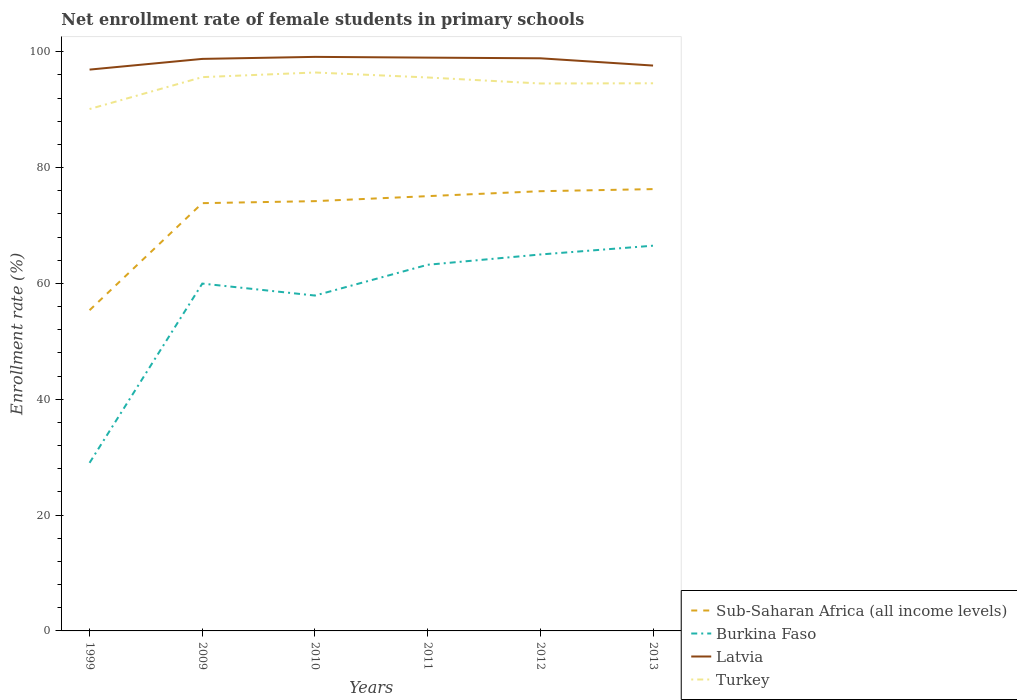How many different coloured lines are there?
Provide a succinct answer. 4. Does the line corresponding to Latvia intersect with the line corresponding to Sub-Saharan Africa (all income levels)?
Provide a succinct answer. No. Is the number of lines equal to the number of legend labels?
Offer a very short reply. Yes. Across all years, what is the maximum net enrollment rate of female students in primary schools in Latvia?
Offer a terse response. 96.93. What is the total net enrollment rate of female students in primary schools in Burkina Faso in the graph?
Ensure brevity in your answer.  -1.78. What is the difference between the highest and the second highest net enrollment rate of female students in primary schools in Sub-Saharan Africa (all income levels)?
Provide a succinct answer. 20.91. How many years are there in the graph?
Your response must be concise. 6. Are the values on the major ticks of Y-axis written in scientific E-notation?
Your response must be concise. No. Does the graph contain any zero values?
Your response must be concise. No. What is the title of the graph?
Provide a short and direct response. Net enrollment rate of female students in primary schools. What is the label or title of the Y-axis?
Your answer should be compact. Enrollment rate (%). What is the Enrollment rate (%) in Sub-Saharan Africa (all income levels) in 1999?
Make the answer very short. 55.38. What is the Enrollment rate (%) in Burkina Faso in 1999?
Offer a terse response. 29.03. What is the Enrollment rate (%) of Latvia in 1999?
Offer a terse response. 96.93. What is the Enrollment rate (%) in Turkey in 1999?
Offer a very short reply. 90.12. What is the Enrollment rate (%) of Sub-Saharan Africa (all income levels) in 2009?
Make the answer very short. 73.87. What is the Enrollment rate (%) of Burkina Faso in 2009?
Offer a very short reply. 59.98. What is the Enrollment rate (%) in Latvia in 2009?
Ensure brevity in your answer.  98.78. What is the Enrollment rate (%) in Turkey in 2009?
Ensure brevity in your answer.  95.63. What is the Enrollment rate (%) in Sub-Saharan Africa (all income levels) in 2010?
Provide a succinct answer. 74.21. What is the Enrollment rate (%) in Burkina Faso in 2010?
Offer a very short reply. 57.91. What is the Enrollment rate (%) of Latvia in 2010?
Make the answer very short. 99.13. What is the Enrollment rate (%) in Turkey in 2010?
Your response must be concise. 96.43. What is the Enrollment rate (%) of Sub-Saharan Africa (all income levels) in 2011?
Offer a very short reply. 75.08. What is the Enrollment rate (%) in Burkina Faso in 2011?
Make the answer very short. 63.23. What is the Enrollment rate (%) in Latvia in 2011?
Your response must be concise. 99. What is the Enrollment rate (%) of Turkey in 2011?
Make the answer very short. 95.57. What is the Enrollment rate (%) in Sub-Saharan Africa (all income levels) in 2012?
Offer a terse response. 75.93. What is the Enrollment rate (%) in Burkina Faso in 2012?
Offer a very short reply. 65. What is the Enrollment rate (%) in Latvia in 2012?
Keep it short and to the point. 98.88. What is the Enrollment rate (%) of Turkey in 2012?
Give a very brief answer. 94.53. What is the Enrollment rate (%) in Sub-Saharan Africa (all income levels) in 2013?
Make the answer very short. 76.29. What is the Enrollment rate (%) in Burkina Faso in 2013?
Provide a succinct answer. 66.52. What is the Enrollment rate (%) of Latvia in 2013?
Ensure brevity in your answer.  97.63. What is the Enrollment rate (%) in Turkey in 2013?
Provide a succinct answer. 94.57. Across all years, what is the maximum Enrollment rate (%) of Sub-Saharan Africa (all income levels)?
Ensure brevity in your answer.  76.29. Across all years, what is the maximum Enrollment rate (%) of Burkina Faso?
Provide a short and direct response. 66.52. Across all years, what is the maximum Enrollment rate (%) in Latvia?
Offer a terse response. 99.13. Across all years, what is the maximum Enrollment rate (%) in Turkey?
Your answer should be very brief. 96.43. Across all years, what is the minimum Enrollment rate (%) of Sub-Saharan Africa (all income levels)?
Give a very brief answer. 55.38. Across all years, what is the minimum Enrollment rate (%) in Burkina Faso?
Your answer should be compact. 29.03. Across all years, what is the minimum Enrollment rate (%) of Latvia?
Your response must be concise. 96.93. Across all years, what is the minimum Enrollment rate (%) of Turkey?
Offer a very short reply. 90.12. What is the total Enrollment rate (%) in Sub-Saharan Africa (all income levels) in the graph?
Make the answer very short. 430.76. What is the total Enrollment rate (%) of Burkina Faso in the graph?
Offer a very short reply. 341.67. What is the total Enrollment rate (%) in Latvia in the graph?
Your answer should be compact. 590.34. What is the total Enrollment rate (%) in Turkey in the graph?
Provide a succinct answer. 566.85. What is the difference between the Enrollment rate (%) in Sub-Saharan Africa (all income levels) in 1999 and that in 2009?
Offer a terse response. -18.49. What is the difference between the Enrollment rate (%) of Burkina Faso in 1999 and that in 2009?
Keep it short and to the point. -30.95. What is the difference between the Enrollment rate (%) of Latvia in 1999 and that in 2009?
Your response must be concise. -1.85. What is the difference between the Enrollment rate (%) in Turkey in 1999 and that in 2009?
Provide a short and direct response. -5.51. What is the difference between the Enrollment rate (%) in Sub-Saharan Africa (all income levels) in 1999 and that in 2010?
Offer a terse response. -18.83. What is the difference between the Enrollment rate (%) of Burkina Faso in 1999 and that in 2010?
Make the answer very short. -28.89. What is the difference between the Enrollment rate (%) in Latvia in 1999 and that in 2010?
Offer a terse response. -2.2. What is the difference between the Enrollment rate (%) in Turkey in 1999 and that in 2010?
Provide a short and direct response. -6.31. What is the difference between the Enrollment rate (%) in Sub-Saharan Africa (all income levels) in 1999 and that in 2011?
Your answer should be compact. -19.7. What is the difference between the Enrollment rate (%) in Burkina Faso in 1999 and that in 2011?
Keep it short and to the point. -34.2. What is the difference between the Enrollment rate (%) in Latvia in 1999 and that in 2011?
Give a very brief answer. -2.07. What is the difference between the Enrollment rate (%) of Turkey in 1999 and that in 2011?
Your response must be concise. -5.45. What is the difference between the Enrollment rate (%) of Sub-Saharan Africa (all income levels) in 1999 and that in 2012?
Make the answer very short. -20.55. What is the difference between the Enrollment rate (%) in Burkina Faso in 1999 and that in 2012?
Offer a very short reply. -35.98. What is the difference between the Enrollment rate (%) of Latvia in 1999 and that in 2012?
Give a very brief answer. -1.95. What is the difference between the Enrollment rate (%) in Turkey in 1999 and that in 2012?
Your answer should be very brief. -4.41. What is the difference between the Enrollment rate (%) in Sub-Saharan Africa (all income levels) in 1999 and that in 2013?
Ensure brevity in your answer.  -20.91. What is the difference between the Enrollment rate (%) of Burkina Faso in 1999 and that in 2013?
Offer a very short reply. -37.5. What is the difference between the Enrollment rate (%) in Latvia in 1999 and that in 2013?
Your answer should be compact. -0.7. What is the difference between the Enrollment rate (%) in Turkey in 1999 and that in 2013?
Give a very brief answer. -4.45. What is the difference between the Enrollment rate (%) of Sub-Saharan Africa (all income levels) in 2009 and that in 2010?
Offer a very short reply. -0.35. What is the difference between the Enrollment rate (%) of Burkina Faso in 2009 and that in 2010?
Your answer should be very brief. 2.07. What is the difference between the Enrollment rate (%) of Latvia in 2009 and that in 2010?
Your response must be concise. -0.35. What is the difference between the Enrollment rate (%) in Turkey in 2009 and that in 2010?
Give a very brief answer. -0.8. What is the difference between the Enrollment rate (%) in Sub-Saharan Africa (all income levels) in 2009 and that in 2011?
Give a very brief answer. -1.21. What is the difference between the Enrollment rate (%) of Burkina Faso in 2009 and that in 2011?
Offer a terse response. -3.25. What is the difference between the Enrollment rate (%) of Latvia in 2009 and that in 2011?
Ensure brevity in your answer.  -0.22. What is the difference between the Enrollment rate (%) of Turkey in 2009 and that in 2011?
Provide a succinct answer. 0.06. What is the difference between the Enrollment rate (%) of Sub-Saharan Africa (all income levels) in 2009 and that in 2012?
Make the answer very short. -2.06. What is the difference between the Enrollment rate (%) in Burkina Faso in 2009 and that in 2012?
Give a very brief answer. -5.03. What is the difference between the Enrollment rate (%) in Latvia in 2009 and that in 2012?
Provide a short and direct response. -0.1. What is the difference between the Enrollment rate (%) in Turkey in 2009 and that in 2012?
Provide a succinct answer. 1.1. What is the difference between the Enrollment rate (%) of Sub-Saharan Africa (all income levels) in 2009 and that in 2013?
Your answer should be very brief. -2.43. What is the difference between the Enrollment rate (%) in Burkina Faso in 2009 and that in 2013?
Provide a short and direct response. -6.54. What is the difference between the Enrollment rate (%) of Latvia in 2009 and that in 2013?
Your answer should be compact. 1.15. What is the difference between the Enrollment rate (%) of Turkey in 2009 and that in 2013?
Keep it short and to the point. 1.06. What is the difference between the Enrollment rate (%) of Sub-Saharan Africa (all income levels) in 2010 and that in 2011?
Offer a terse response. -0.86. What is the difference between the Enrollment rate (%) in Burkina Faso in 2010 and that in 2011?
Provide a short and direct response. -5.32. What is the difference between the Enrollment rate (%) in Latvia in 2010 and that in 2011?
Your answer should be very brief. 0.13. What is the difference between the Enrollment rate (%) of Turkey in 2010 and that in 2011?
Provide a short and direct response. 0.86. What is the difference between the Enrollment rate (%) in Sub-Saharan Africa (all income levels) in 2010 and that in 2012?
Make the answer very short. -1.72. What is the difference between the Enrollment rate (%) of Burkina Faso in 2010 and that in 2012?
Your response must be concise. -7.09. What is the difference between the Enrollment rate (%) in Latvia in 2010 and that in 2012?
Your response must be concise. 0.24. What is the difference between the Enrollment rate (%) in Turkey in 2010 and that in 2012?
Provide a succinct answer. 1.9. What is the difference between the Enrollment rate (%) in Sub-Saharan Africa (all income levels) in 2010 and that in 2013?
Your answer should be compact. -2.08. What is the difference between the Enrollment rate (%) of Burkina Faso in 2010 and that in 2013?
Offer a very short reply. -8.61. What is the difference between the Enrollment rate (%) of Latvia in 2010 and that in 2013?
Provide a short and direct response. 1.5. What is the difference between the Enrollment rate (%) in Turkey in 2010 and that in 2013?
Ensure brevity in your answer.  1.86. What is the difference between the Enrollment rate (%) of Sub-Saharan Africa (all income levels) in 2011 and that in 2012?
Provide a short and direct response. -0.85. What is the difference between the Enrollment rate (%) of Burkina Faso in 2011 and that in 2012?
Give a very brief answer. -1.78. What is the difference between the Enrollment rate (%) in Latvia in 2011 and that in 2012?
Offer a terse response. 0.12. What is the difference between the Enrollment rate (%) of Turkey in 2011 and that in 2012?
Offer a very short reply. 1.04. What is the difference between the Enrollment rate (%) in Sub-Saharan Africa (all income levels) in 2011 and that in 2013?
Provide a succinct answer. -1.22. What is the difference between the Enrollment rate (%) of Burkina Faso in 2011 and that in 2013?
Your response must be concise. -3.29. What is the difference between the Enrollment rate (%) in Latvia in 2011 and that in 2013?
Offer a terse response. 1.37. What is the difference between the Enrollment rate (%) of Sub-Saharan Africa (all income levels) in 2012 and that in 2013?
Offer a terse response. -0.36. What is the difference between the Enrollment rate (%) in Burkina Faso in 2012 and that in 2013?
Your answer should be very brief. -1.52. What is the difference between the Enrollment rate (%) of Latvia in 2012 and that in 2013?
Keep it short and to the point. 1.26. What is the difference between the Enrollment rate (%) in Turkey in 2012 and that in 2013?
Your response must be concise. -0.03. What is the difference between the Enrollment rate (%) of Sub-Saharan Africa (all income levels) in 1999 and the Enrollment rate (%) of Burkina Faso in 2009?
Offer a terse response. -4.6. What is the difference between the Enrollment rate (%) of Sub-Saharan Africa (all income levels) in 1999 and the Enrollment rate (%) of Latvia in 2009?
Your response must be concise. -43.4. What is the difference between the Enrollment rate (%) in Sub-Saharan Africa (all income levels) in 1999 and the Enrollment rate (%) in Turkey in 2009?
Make the answer very short. -40.25. What is the difference between the Enrollment rate (%) in Burkina Faso in 1999 and the Enrollment rate (%) in Latvia in 2009?
Make the answer very short. -69.75. What is the difference between the Enrollment rate (%) in Burkina Faso in 1999 and the Enrollment rate (%) in Turkey in 2009?
Provide a succinct answer. -66.6. What is the difference between the Enrollment rate (%) in Latvia in 1999 and the Enrollment rate (%) in Turkey in 2009?
Keep it short and to the point. 1.3. What is the difference between the Enrollment rate (%) in Sub-Saharan Africa (all income levels) in 1999 and the Enrollment rate (%) in Burkina Faso in 2010?
Your response must be concise. -2.53. What is the difference between the Enrollment rate (%) in Sub-Saharan Africa (all income levels) in 1999 and the Enrollment rate (%) in Latvia in 2010?
Offer a very short reply. -43.75. What is the difference between the Enrollment rate (%) in Sub-Saharan Africa (all income levels) in 1999 and the Enrollment rate (%) in Turkey in 2010?
Give a very brief answer. -41.05. What is the difference between the Enrollment rate (%) of Burkina Faso in 1999 and the Enrollment rate (%) of Latvia in 2010?
Provide a short and direct response. -70.1. What is the difference between the Enrollment rate (%) in Burkina Faso in 1999 and the Enrollment rate (%) in Turkey in 2010?
Offer a terse response. -67.4. What is the difference between the Enrollment rate (%) of Latvia in 1999 and the Enrollment rate (%) of Turkey in 2010?
Ensure brevity in your answer.  0.5. What is the difference between the Enrollment rate (%) in Sub-Saharan Africa (all income levels) in 1999 and the Enrollment rate (%) in Burkina Faso in 2011?
Offer a terse response. -7.85. What is the difference between the Enrollment rate (%) of Sub-Saharan Africa (all income levels) in 1999 and the Enrollment rate (%) of Latvia in 2011?
Give a very brief answer. -43.62. What is the difference between the Enrollment rate (%) in Sub-Saharan Africa (all income levels) in 1999 and the Enrollment rate (%) in Turkey in 2011?
Your answer should be compact. -40.19. What is the difference between the Enrollment rate (%) of Burkina Faso in 1999 and the Enrollment rate (%) of Latvia in 2011?
Give a very brief answer. -69.97. What is the difference between the Enrollment rate (%) in Burkina Faso in 1999 and the Enrollment rate (%) in Turkey in 2011?
Provide a succinct answer. -66.54. What is the difference between the Enrollment rate (%) of Latvia in 1999 and the Enrollment rate (%) of Turkey in 2011?
Provide a short and direct response. 1.36. What is the difference between the Enrollment rate (%) of Sub-Saharan Africa (all income levels) in 1999 and the Enrollment rate (%) of Burkina Faso in 2012?
Give a very brief answer. -9.62. What is the difference between the Enrollment rate (%) of Sub-Saharan Africa (all income levels) in 1999 and the Enrollment rate (%) of Latvia in 2012?
Make the answer very short. -43.5. What is the difference between the Enrollment rate (%) in Sub-Saharan Africa (all income levels) in 1999 and the Enrollment rate (%) in Turkey in 2012?
Offer a very short reply. -39.15. What is the difference between the Enrollment rate (%) of Burkina Faso in 1999 and the Enrollment rate (%) of Latvia in 2012?
Give a very brief answer. -69.86. What is the difference between the Enrollment rate (%) of Burkina Faso in 1999 and the Enrollment rate (%) of Turkey in 2012?
Make the answer very short. -65.51. What is the difference between the Enrollment rate (%) in Latvia in 1999 and the Enrollment rate (%) in Turkey in 2012?
Give a very brief answer. 2.4. What is the difference between the Enrollment rate (%) in Sub-Saharan Africa (all income levels) in 1999 and the Enrollment rate (%) in Burkina Faso in 2013?
Offer a very short reply. -11.14. What is the difference between the Enrollment rate (%) in Sub-Saharan Africa (all income levels) in 1999 and the Enrollment rate (%) in Latvia in 2013?
Your answer should be very brief. -42.25. What is the difference between the Enrollment rate (%) in Sub-Saharan Africa (all income levels) in 1999 and the Enrollment rate (%) in Turkey in 2013?
Offer a very short reply. -39.19. What is the difference between the Enrollment rate (%) of Burkina Faso in 1999 and the Enrollment rate (%) of Latvia in 2013?
Your answer should be very brief. -68.6. What is the difference between the Enrollment rate (%) in Burkina Faso in 1999 and the Enrollment rate (%) in Turkey in 2013?
Your answer should be compact. -65.54. What is the difference between the Enrollment rate (%) of Latvia in 1999 and the Enrollment rate (%) of Turkey in 2013?
Make the answer very short. 2.36. What is the difference between the Enrollment rate (%) of Sub-Saharan Africa (all income levels) in 2009 and the Enrollment rate (%) of Burkina Faso in 2010?
Give a very brief answer. 15.95. What is the difference between the Enrollment rate (%) of Sub-Saharan Africa (all income levels) in 2009 and the Enrollment rate (%) of Latvia in 2010?
Your response must be concise. -25.26. What is the difference between the Enrollment rate (%) of Sub-Saharan Africa (all income levels) in 2009 and the Enrollment rate (%) of Turkey in 2010?
Your answer should be very brief. -22.56. What is the difference between the Enrollment rate (%) in Burkina Faso in 2009 and the Enrollment rate (%) in Latvia in 2010?
Provide a succinct answer. -39.15. What is the difference between the Enrollment rate (%) in Burkina Faso in 2009 and the Enrollment rate (%) in Turkey in 2010?
Keep it short and to the point. -36.45. What is the difference between the Enrollment rate (%) in Latvia in 2009 and the Enrollment rate (%) in Turkey in 2010?
Your response must be concise. 2.35. What is the difference between the Enrollment rate (%) in Sub-Saharan Africa (all income levels) in 2009 and the Enrollment rate (%) in Burkina Faso in 2011?
Ensure brevity in your answer.  10.64. What is the difference between the Enrollment rate (%) in Sub-Saharan Africa (all income levels) in 2009 and the Enrollment rate (%) in Latvia in 2011?
Offer a very short reply. -25.13. What is the difference between the Enrollment rate (%) in Sub-Saharan Africa (all income levels) in 2009 and the Enrollment rate (%) in Turkey in 2011?
Provide a succinct answer. -21.7. What is the difference between the Enrollment rate (%) of Burkina Faso in 2009 and the Enrollment rate (%) of Latvia in 2011?
Offer a very short reply. -39.02. What is the difference between the Enrollment rate (%) of Burkina Faso in 2009 and the Enrollment rate (%) of Turkey in 2011?
Your answer should be compact. -35.59. What is the difference between the Enrollment rate (%) of Latvia in 2009 and the Enrollment rate (%) of Turkey in 2011?
Make the answer very short. 3.21. What is the difference between the Enrollment rate (%) of Sub-Saharan Africa (all income levels) in 2009 and the Enrollment rate (%) of Burkina Faso in 2012?
Offer a very short reply. 8.86. What is the difference between the Enrollment rate (%) of Sub-Saharan Africa (all income levels) in 2009 and the Enrollment rate (%) of Latvia in 2012?
Keep it short and to the point. -25.02. What is the difference between the Enrollment rate (%) of Sub-Saharan Africa (all income levels) in 2009 and the Enrollment rate (%) of Turkey in 2012?
Make the answer very short. -20.67. What is the difference between the Enrollment rate (%) of Burkina Faso in 2009 and the Enrollment rate (%) of Latvia in 2012?
Keep it short and to the point. -38.9. What is the difference between the Enrollment rate (%) of Burkina Faso in 2009 and the Enrollment rate (%) of Turkey in 2012?
Keep it short and to the point. -34.55. What is the difference between the Enrollment rate (%) of Latvia in 2009 and the Enrollment rate (%) of Turkey in 2012?
Your answer should be compact. 4.25. What is the difference between the Enrollment rate (%) in Sub-Saharan Africa (all income levels) in 2009 and the Enrollment rate (%) in Burkina Faso in 2013?
Offer a terse response. 7.34. What is the difference between the Enrollment rate (%) in Sub-Saharan Africa (all income levels) in 2009 and the Enrollment rate (%) in Latvia in 2013?
Keep it short and to the point. -23.76. What is the difference between the Enrollment rate (%) in Sub-Saharan Africa (all income levels) in 2009 and the Enrollment rate (%) in Turkey in 2013?
Give a very brief answer. -20.7. What is the difference between the Enrollment rate (%) of Burkina Faso in 2009 and the Enrollment rate (%) of Latvia in 2013?
Provide a short and direct response. -37.65. What is the difference between the Enrollment rate (%) in Burkina Faso in 2009 and the Enrollment rate (%) in Turkey in 2013?
Your answer should be compact. -34.59. What is the difference between the Enrollment rate (%) of Latvia in 2009 and the Enrollment rate (%) of Turkey in 2013?
Keep it short and to the point. 4.21. What is the difference between the Enrollment rate (%) in Sub-Saharan Africa (all income levels) in 2010 and the Enrollment rate (%) in Burkina Faso in 2011?
Provide a succinct answer. 10.99. What is the difference between the Enrollment rate (%) of Sub-Saharan Africa (all income levels) in 2010 and the Enrollment rate (%) of Latvia in 2011?
Your response must be concise. -24.78. What is the difference between the Enrollment rate (%) of Sub-Saharan Africa (all income levels) in 2010 and the Enrollment rate (%) of Turkey in 2011?
Provide a short and direct response. -21.36. What is the difference between the Enrollment rate (%) in Burkina Faso in 2010 and the Enrollment rate (%) in Latvia in 2011?
Give a very brief answer. -41.09. What is the difference between the Enrollment rate (%) of Burkina Faso in 2010 and the Enrollment rate (%) of Turkey in 2011?
Keep it short and to the point. -37.66. What is the difference between the Enrollment rate (%) in Latvia in 2010 and the Enrollment rate (%) in Turkey in 2011?
Ensure brevity in your answer.  3.56. What is the difference between the Enrollment rate (%) in Sub-Saharan Africa (all income levels) in 2010 and the Enrollment rate (%) in Burkina Faso in 2012?
Offer a terse response. 9.21. What is the difference between the Enrollment rate (%) in Sub-Saharan Africa (all income levels) in 2010 and the Enrollment rate (%) in Latvia in 2012?
Keep it short and to the point. -24.67. What is the difference between the Enrollment rate (%) in Sub-Saharan Africa (all income levels) in 2010 and the Enrollment rate (%) in Turkey in 2012?
Keep it short and to the point. -20.32. What is the difference between the Enrollment rate (%) in Burkina Faso in 2010 and the Enrollment rate (%) in Latvia in 2012?
Your response must be concise. -40.97. What is the difference between the Enrollment rate (%) of Burkina Faso in 2010 and the Enrollment rate (%) of Turkey in 2012?
Keep it short and to the point. -36.62. What is the difference between the Enrollment rate (%) of Latvia in 2010 and the Enrollment rate (%) of Turkey in 2012?
Provide a succinct answer. 4.59. What is the difference between the Enrollment rate (%) of Sub-Saharan Africa (all income levels) in 2010 and the Enrollment rate (%) of Burkina Faso in 2013?
Offer a very short reply. 7.69. What is the difference between the Enrollment rate (%) of Sub-Saharan Africa (all income levels) in 2010 and the Enrollment rate (%) of Latvia in 2013?
Your response must be concise. -23.41. What is the difference between the Enrollment rate (%) of Sub-Saharan Africa (all income levels) in 2010 and the Enrollment rate (%) of Turkey in 2013?
Keep it short and to the point. -20.35. What is the difference between the Enrollment rate (%) in Burkina Faso in 2010 and the Enrollment rate (%) in Latvia in 2013?
Make the answer very short. -39.71. What is the difference between the Enrollment rate (%) in Burkina Faso in 2010 and the Enrollment rate (%) in Turkey in 2013?
Provide a succinct answer. -36.65. What is the difference between the Enrollment rate (%) of Latvia in 2010 and the Enrollment rate (%) of Turkey in 2013?
Give a very brief answer. 4.56. What is the difference between the Enrollment rate (%) in Sub-Saharan Africa (all income levels) in 2011 and the Enrollment rate (%) in Burkina Faso in 2012?
Provide a short and direct response. 10.07. What is the difference between the Enrollment rate (%) in Sub-Saharan Africa (all income levels) in 2011 and the Enrollment rate (%) in Latvia in 2012?
Keep it short and to the point. -23.8. What is the difference between the Enrollment rate (%) of Sub-Saharan Africa (all income levels) in 2011 and the Enrollment rate (%) of Turkey in 2012?
Your response must be concise. -19.46. What is the difference between the Enrollment rate (%) in Burkina Faso in 2011 and the Enrollment rate (%) in Latvia in 2012?
Offer a very short reply. -35.65. What is the difference between the Enrollment rate (%) of Burkina Faso in 2011 and the Enrollment rate (%) of Turkey in 2012?
Make the answer very short. -31.3. What is the difference between the Enrollment rate (%) in Latvia in 2011 and the Enrollment rate (%) in Turkey in 2012?
Keep it short and to the point. 4.47. What is the difference between the Enrollment rate (%) of Sub-Saharan Africa (all income levels) in 2011 and the Enrollment rate (%) of Burkina Faso in 2013?
Keep it short and to the point. 8.56. What is the difference between the Enrollment rate (%) of Sub-Saharan Africa (all income levels) in 2011 and the Enrollment rate (%) of Latvia in 2013?
Ensure brevity in your answer.  -22.55. What is the difference between the Enrollment rate (%) of Sub-Saharan Africa (all income levels) in 2011 and the Enrollment rate (%) of Turkey in 2013?
Ensure brevity in your answer.  -19.49. What is the difference between the Enrollment rate (%) of Burkina Faso in 2011 and the Enrollment rate (%) of Latvia in 2013?
Your answer should be compact. -34.4. What is the difference between the Enrollment rate (%) in Burkina Faso in 2011 and the Enrollment rate (%) in Turkey in 2013?
Keep it short and to the point. -31.34. What is the difference between the Enrollment rate (%) in Latvia in 2011 and the Enrollment rate (%) in Turkey in 2013?
Offer a very short reply. 4.43. What is the difference between the Enrollment rate (%) in Sub-Saharan Africa (all income levels) in 2012 and the Enrollment rate (%) in Burkina Faso in 2013?
Provide a succinct answer. 9.41. What is the difference between the Enrollment rate (%) of Sub-Saharan Africa (all income levels) in 2012 and the Enrollment rate (%) of Latvia in 2013?
Keep it short and to the point. -21.7. What is the difference between the Enrollment rate (%) of Sub-Saharan Africa (all income levels) in 2012 and the Enrollment rate (%) of Turkey in 2013?
Your answer should be compact. -18.64. What is the difference between the Enrollment rate (%) of Burkina Faso in 2012 and the Enrollment rate (%) of Latvia in 2013?
Keep it short and to the point. -32.62. What is the difference between the Enrollment rate (%) of Burkina Faso in 2012 and the Enrollment rate (%) of Turkey in 2013?
Make the answer very short. -29.56. What is the difference between the Enrollment rate (%) in Latvia in 2012 and the Enrollment rate (%) in Turkey in 2013?
Provide a succinct answer. 4.32. What is the average Enrollment rate (%) in Sub-Saharan Africa (all income levels) per year?
Your response must be concise. 71.79. What is the average Enrollment rate (%) of Burkina Faso per year?
Provide a short and direct response. 56.95. What is the average Enrollment rate (%) in Latvia per year?
Make the answer very short. 98.39. What is the average Enrollment rate (%) of Turkey per year?
Offer a terse response. 94.47. In the year 1999, what is the difference between the Enrollment rate (%) of Sub-Saharan Africa (all income levels) and Enrollment rate (%) of Burkina Faso?
Make the answer very short. 26.35. In the year 1999, what is the difference between the Enrollment rate (%) of Sub-Saharan Africa (all income levels) and Enrollment rate (%) of Latvia?
Keep it short and to the point. -41.55. In the year 1999, what is the difference between the Enrollment rate (%) in Sub-Saharan Africa (all income levels) and Enrollment rate (%) in Turkey?
Keep it short and to the point. -34.74. In the year 1999, what is the difference between the Enrollment rate (%) in Burkina Faso and Enrollment rate (%) in Latvia?
Provide a short and direct response. -67.9. In the year 1999, what is the difference between the Enrollment rate (%) of Burkina Faso and Enrollment rate (%) of Turkey?
Make the answer very short. -61.09. In the year 1999, what is the difference between the Enrollment rate (%) in Latvia and Enrollment rate (%) in Turkey?
Your answer should be compact. 6.81. In the year 2009, what is the difference between the Enrollment rate (%) of Sub-Saharan Africa (all income levels) and Enrollment rate (%) of Burkina Faso?
Offer a very short reply. 13.89. In the year 2009, what is the difference between the Enrollment rate (%) in Sub-Saharan Africa (all income levels) and Enrollment rate (%) in Latvia?
Offer a very short reply. -24.91. In the year 2009, what is the difference between the Enrollment rate (%) in Sub-Saharan Africa (all income levels) and Enrollment rate (%) in Turkey?
Make the answer very short. -21.76. In the year 2009, what is the difference between the Enrollment rate (%) of Burkina Faso and Enrollment rate (%) of Latvia?
Keep it short and to the point. -38.8. In the year 2009, what is the difference between the Enrollment rate (%) of Burkina Faso and Enrollment rate (%) of Turkey?
Your answer should be compact. -35.65. In the year 2009, what is the difference between the Enrollment rate (%) of Latvia and Enrollment rate (%) of Turkey?
Give a very brief answer. 3.15. In the year 2010, what is the difference between the Enrollment rate (%) of Sub-Saharan Africa (all income levels) and Enrollment rate (%) of Burkina Faso?
Give a very brief answer. 16.3. In the year 2010, what is the difference between the Enrollment rate (%) of Sub-Saharan Africa (all income levels) and Enrollment rate (%) of Latvia?
Offer a terse response. -24.91. In the year 2010, what is the difference between the Enrollment rate (%) in Sub-Saharan Africa (all income levels) and Enrollment rate (%) in Turkey?
Keep it short and to the point. -22.22. In the year 2010, what is the difference between the Enrollment rate (%) of Burkina Faso and Enrollment rate (%) of Latvia?
Your answer should be compact. -41.21. In the year 2010, what is the difference between the Enrollment rate (%) in Burkina Faso and Enrollment rate (%) in Turkey?
Your response must be concise. -38.52. In the year 2010, what is the difference between the Enrollment rate (%) of Latvia and Enrollment rate (%) of Turkey?
Make the answer very short. 2.7. In the year 2011, what is the difference between the Enrollment rate (%) of Sub-Saharan Africa (all income levels) and Enrollment rate (%) of Burkina Faso?
Your answer should be compact. 11.85. In the year 2011, what is the difference between the Enrollment rate (%) in Sub-Saharan Africa (all income levels) and Enrollment rate (%) in Latvia?
Offer a very short reply. -23.92. In the year 2011, what is the difference between the Enrollment rate (%) in Sub-Saharan Africa (all income levels) and Enrollment rate (%) in Turkey?
Your answer should be very brief. -20.49. In the year 2011, what is the difference between the Enrollment rate (%) of Burkina Faso and Enrollment rate (%) of Latvia?
Your response must be concise. -35.77. In the year 2011, what is the difference between the Enrollment rate (%) in Burkina Faso and Enrollment rate (%) in Turkey?
Provide a short and direct response. -32.34. In the year 2011, what is the difference between the Enrollment rate (%) in Latvia and Enrollment rate (%) in Turkey?
Your response must be concise. 3.43. In the year 2012, what is the difference between the Enrollment rate (%) in Sub-Saharan Africa (all income levels) and Enrollment rate (%) in Burkina Faso?
Make the answer very short. 10.93. In the year 2012, what is the difference between the Enrollment rate (%) in Sub-Saharan Africa (all income levels) and Enrollment rate (%) in Latvia?
Offer a very short reply. -22.95. In the year 2012, what is the difference between the Enrollment rate (%) of Sub-Saharan Africa (all income levels) and Enrollment rate (%) of Turkey?
Keep it short and to the point. -18.6. In the year 2012, what is the difference between the Enrollment rate (%) in Burkina Faso and Enrollment rate (%) in Latvia?
Offer a terse response. -33.88. In the year 2012, what is the difference between the Enrollment rate (%) in Burkina Faso and Enrollment rate (%) in Turkey?
Your answer should be compact. -29.53. In the year 2012, what is the difference between the Enrollment rate (%) in Latvia and Enrollment rate (%) in Turkey?
Offer a very short reply. 4.35. In the year 2013, what is the difference between the Enrollment rate (%) in Sub-Saharan Africa (all income levels) and Enrollment rate (%) in Burkina Faso?
Offer a terse response. 9.77. In the year 2013, what is the difference between the Enrollment rate (%) of Sub-Saharan Africa (all income levels) and Enrollment rate (%) of Latvia?
Offer a terse response. -21.33. In the year 2013, what is the difference between the Enrollment rate (%) in Sub-Saharan Africa (all income levels) and Enrollment rate (%) in Turkey?
Offer a very short reply. -18.27. In the year 2013, what is the difference between the Enrollment rate (%) in Burkina Faso and Enrollment rate (%) in Latvia?
Keep it short and to the point. -31.1. In the year 2013, what is the difference between the Enrollment rate (%) of Burkina Faso and Enrollment rate (%) of Turkey?
Your response must be concise. -28.04. In the year 2013, what is the difference between the Enrollment rate (%) of Latvia and Enrollment rate (%) of Turkey?
Your response must be concise. 3.06. What is the ratio of the Enrollment rate (%) in Sub-Saharan Africa (all income levels) in 1999 to that in 2009?
Keep it short and to the point. 0.75. What is the ratio of the Enrollment rate (%) in Burkina Faso in 1999 to that in 2009?
Offer a terse response. 0.48. What is the ratio of the Enrollment rate (%) in Latvia in 1999 to that in 2009?
Provide a succinct answer. 0.98. What is the ratio of the Enrollment rate (%) in Turkey in 1999 to that in 2009?
Your answer should be very brief. 0.94. What is the ratio of the Enrollment rate (%) in Sub-Saharan Africa (all income levels) in 1999 to that in 2010?
Your response must be concise. 0.75. What is the ratio of the Enrollment rate (%) of Burkina Faso in 1999 to that in 2010?
Your response must be concise. 0.5. What is the ratio of the Enrollment rate (%) in Latvia in 1999 to that in 2010?
Offer a terse response. 0.98. What is the ratio of the Enrollment rate (%) of Turkey in 1999 to that in 2010?
Keep it short and to the point. 0.93. What is the ratio of the Enrollment rate (%) of Sub-Saharan Africa (all income levels) in 1999 to that in 2011?
Ensure brevity in your answer.  0.74. What is the ratio of the Enrollment rate (%) in Burkina Faso in 1999 to that in 2011?
Your answer should be compact. 0.46. What is the ratio of the Enrollment rate (%) of Latvia in 1999 to that in 2011?
Your response must be concise. 0.98. What is the ratio of the Enrollment rate (%) in Turkey in 1999 to that in 2011?
Keep it short and to the point. 0.94. What is the ratio of the Enrollment rate (%) in Sub-Saharan Africa (all income levels) in 1999 to that in 2012?
Give a very brief answer. 0.73. What is the ratio of the Enrollment rate (%) of Burkina Faso in 1999 to that in 2012?
Your answer should be very brief. 0.45. What is the ratio of the Enrollment rate (%) of Latvia in 1999 to that in 2012?
Offer a terse response. 0.98. What is the ratio of the Enrollment rate (%) of Turkey in 1999 to that in 2012?
Give a very brief answer. 0.95. What is the ratio of the Enrollment rate (%) of Sub-Saharan Africa (all income levels) in 1999 to that in 2013?
Make the answer very short. 0.73. What is the ratio of the Enrollment rate (%) in Burkina Faso in 1999 to that in 2013?
Make the answer very short. 0.44. What is the ratio of the Enrollment rate (%) of Turkey in 1999 to that in 2013?
Your answer should be very brief. 0.95. What is the ratio of the Enrollment rate (%) of Sub-Saharan Africa (all income levels) in 2009 to that in 2010?
Offer a terse response. 1. What is the ratio of the Enrollment rate (%) of Burkina Faso in 2009 to that in 2010?
Provide a succinct answer. 1.04. What is the ratio of the Enrollment rate (%) in Sub-Saharan Africa (all income levels) in 2009 to that in 2011?
Give a very brief answer. 0.98. What is the ratio of the Enrollment rate (%) in Burkina Faso in 2009 to that in 2011?
Keep it short and to the point. 0.95. What is the ratio of the Enrollment rate (%) of Sub-Saharan Africa (all income levels) in 2009 to that in 2012?
Your response must be concise. 0.97. What is the ratio of the Enrollment rate (%) of Burkina Faso in 2009 to that in 2012?
Your answer should be compact. 0.92. What is the ratio of the Enrollment rate (%) of Turkey in 2009 to that in 2012?
Your response must be concise. 1.01. What is the ratio of the Enrollment rate (%) in Sub-Saharan Africa (all income levels) in 2009 to that in 2013?
Provide a succinct answer. 0.97. What is the ratio of the Enrollment rate (%) in Burkina Faso in 2009 to that in 2013?
Your answer should be very brief. 0.9. What is the ratio of the Enrollment rate (%) of Latvia in 2009 to that in 2013?
Your answer should be compact. 1.01. What is the ratio of the Enrollment rate (%) in Turkey in 2009 to that in 2013?
Give a very brief answer. 1.01. What is the ratio of the Enrollment rate (%) in Burkina Faso in 2010 to that in 2011?
Your answer should be very brief. 0.92. What is the ratio of the Enrollment rate (%) of Latvia in 2010 to that in 2011?
Ensure brevity in your answer.  1. What is the ratio of the Enrollment rate (%) of Turkey in 2010 to that in 2011?
Offer a very short reply. 1.01. What is the ratio of the Enrollment rate (%) of Sub-Saharan Africa (all income levels) in 2010 to that in 2012?
Give a very brief answer. 0.98. What is the ratio of the Enrollment rate (%) of Burkina Faso in 2010 to that in 2012?
Ensure brevity in your answer.  0.89. What is the ratio of the Enrollment rate (%) of Latvia in 2010 to that in 2012?
Give a very brief answer. 1. What is the ratio of the Enrollment rate (%) in Turkey in 2010 to that in 2012?
Your answer should be very brief. 1.02. What is the ratio of the Enrollment rate (%) of Sub-Saharan Africa (all income levels) in 2010 to that in 2013?
Your answer should be very brief. 0.97. What is the ratio of the Enrollment rate (%) of Burkina Faso in 2010 to that in 2013?
Make the answer very short. 0.87. What is the ratio of the Enrollment rate (%) of Latvia in 2010 to that in 2013?
Ensure brevity in your answer.  1.02. What is the ratio of the Enrollment rate (%) of Turkey in 2010 to that in 2013?
Your response must be concise. 1.02. What is the ratio of the Enrollment rate (%) in Sub-Saharan Africa (all income levels) in 2011 to that in 2012?
Provide a succinct answer. 0.99. What is the ratio of the Enrollment rate (%) of Burkina Faso in 2011 to that in 2012?
Your answer should be compact. 0.97. What is the ratio of the Enrollment rate (%) in Latvia in 2011 to that in 2012?
Give a very brief answer. 1. What is the ratio of the Enrollment rate (%) of Turkey in 2011 to that in 2012?
Your answer should be very brief. 1.01. What is the ratio of the Enrollment rate (%) of Sub-Saharan Africa (all income levels) in 2011 to that in 2013?
Your answer should be very brief. 0.98. What is the ratio of the Enrollment rate (%) in Burkina Faso in 2011 to that in 2013?
Your answer should be very brief. 0.95. What is the ratio of the Enrollment rate (%) in Latvia in 2011 to that in 2013?
Provide a short and direct response. 1.01. What is the ratio of the Enrollment rate (%) of Turkey in 2011 to that in 2013?
Offer a terse response. 1.01. What is the ratio of the Enrollment rate (%) in Sub-Saharan Africa (all income levels) in 2012 to that in 2013?
Provide a succinct answer. 1. What is the ratio of the Enrollment rate (%) in Burkina Faso in 2012 to that in 2013?
Give a very brief answer. 0.98. What is the ratio of the Enrollment rate (%) of Latvia in 2012 to that in 2013?
Offer a terse response. 1.01. What is the difference between the highest and the second highest Enrollment rate (%) in Sub-Saharan Africa (all income levels)?
Your response must be concise. 0.36. What is the difference between the highest and the second highest Enrollment rate (%) of Burkina Faso?
Offer a very short reply. 1.52. What is the difference between the highest and the second highest Enrollment rate (%) in Latvia?
Offer a terse response. 0.13. What is the difference between the highest and the second highest Enrollment rate (%) in Turkey?
Provide a succinct answer. 0.8. What is the difference between the highest and the lowest Enrollment rate (%) in Sub-Saharan Africa (all income levels)?
Provide a short and direct response. 20.91. What is the difference between the highest and the lowest Enrollment rate (%) of Burkina Faso?
Provide a short and direct response. 37.5. What is the difference between the highest and the lowest Enrollment rate (%) of Latvia?
Keep it short and to the point. 2.2. What is the difference between the highest and the lowest Enrollment rate (%) of Turkey?
Your answer should be very brief. 6.31. 